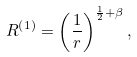<formula> <loc_0><loc_0><loc_500><loc_500>R ^ { \left ( 1 \right ) } = \left ( { \frac { 1 } { r } } \right ) ^ { \frac { 1 } { 2 } + \beta } ,</formula> 